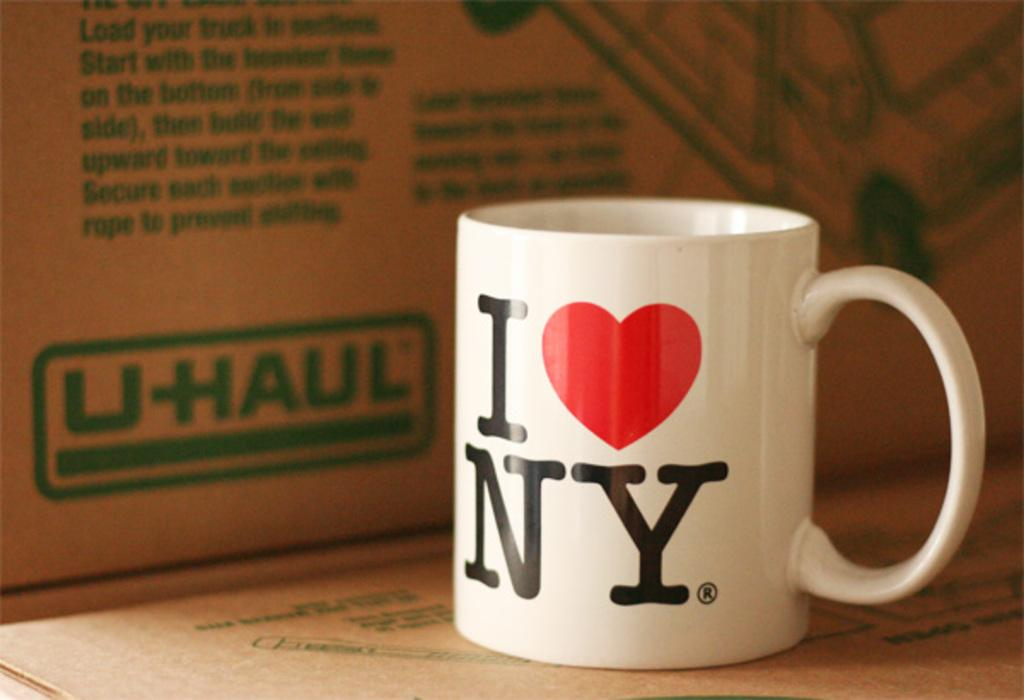<image>
Summarize the visual content of the image. A coffee mug with the logo of i heart new york and is sitting in front of a uhaul box. 